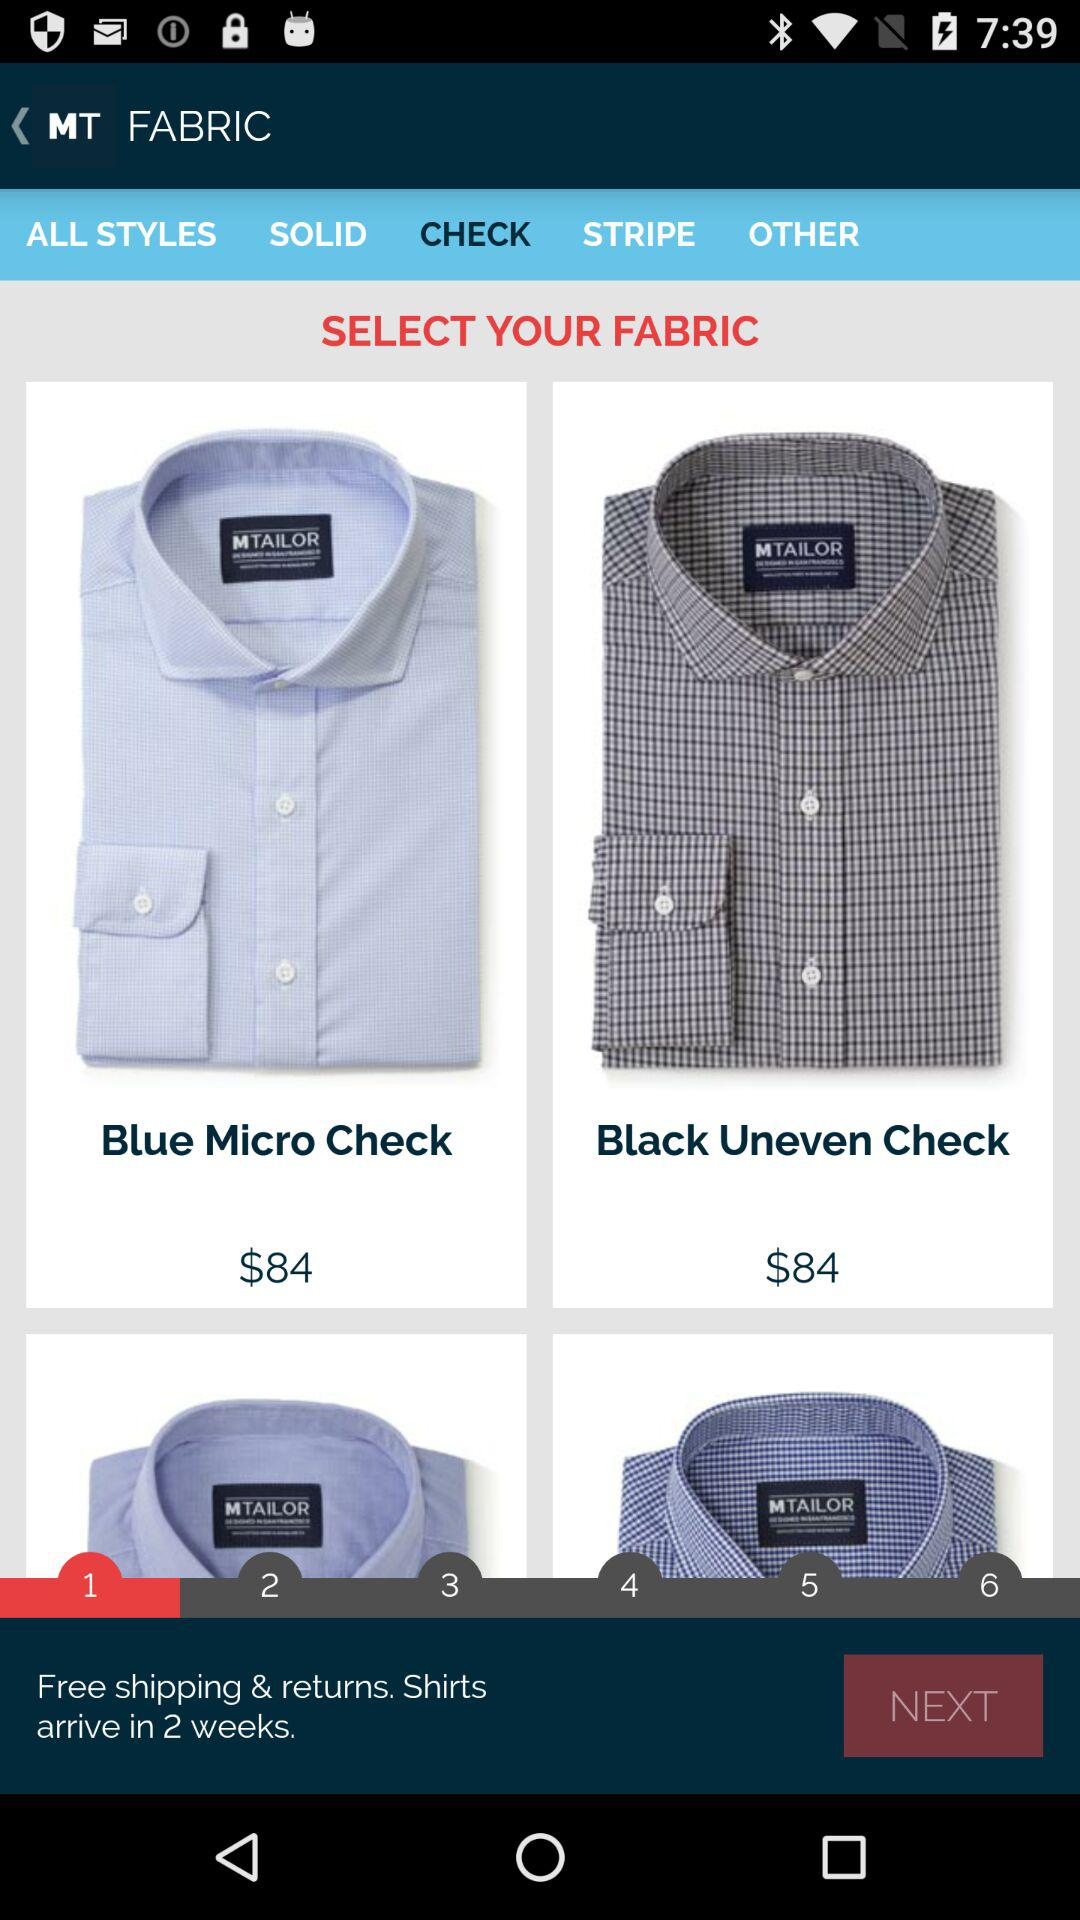What is the price of the "Black Uneven Check"? The price is $84. 